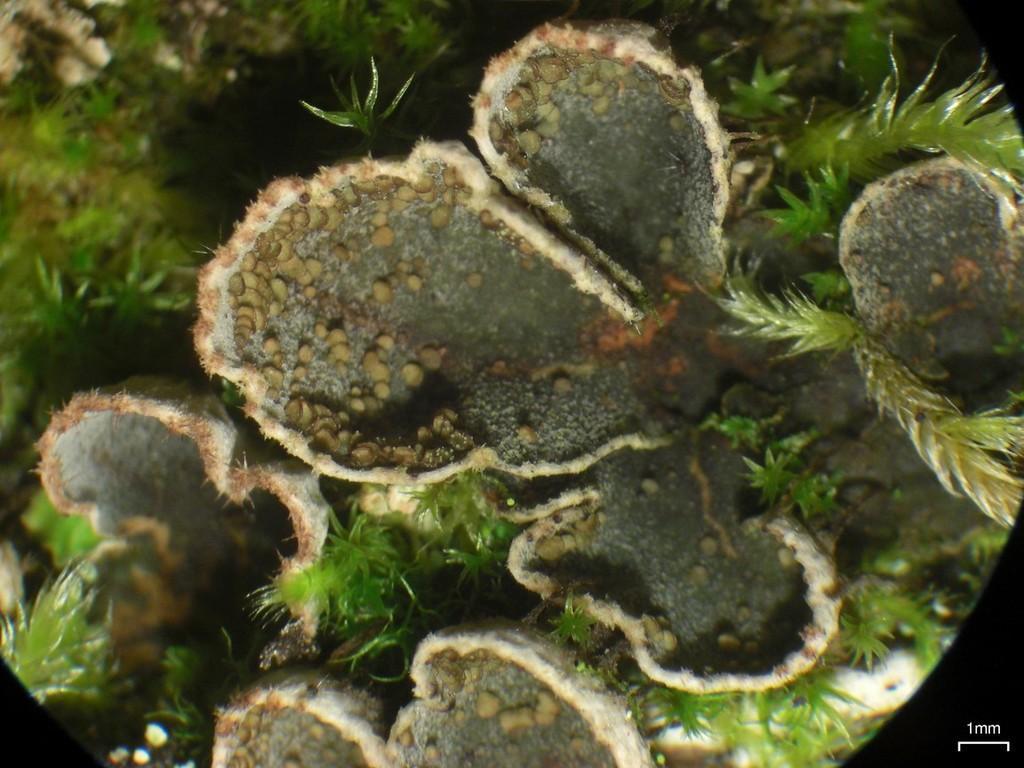Could you give a brief overview of what you see in this image? In this image I can see a plant. The leaves are in green color. 